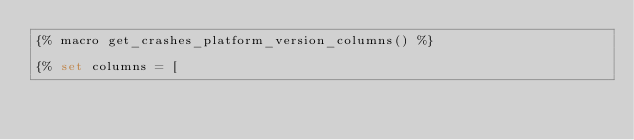Convert code to text. <code><loc_0><loc_0><loc_500><loc_500><_SQL_>{% macro get_crashes_platform_version_columns() %}

{% set columns = [</code> 